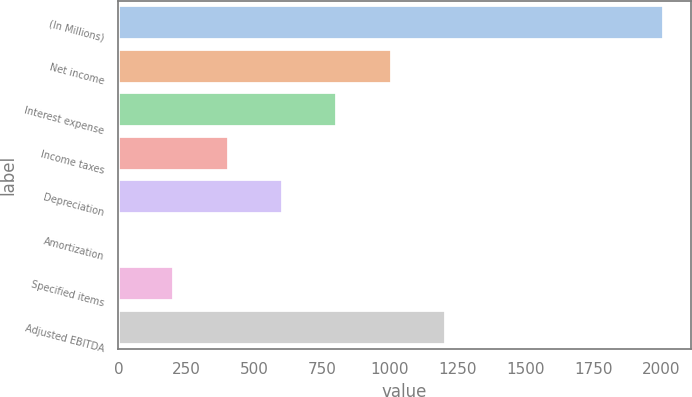Convert chart. <chart><loc_0><loc_0><loc_500><loc_500><bar_chart><fcel>(In Millions)<fcel>Net income<fcel>Interest expense<fcel>Income taxes<fcel>Depreciation<fcel>Amortization<fcel>Specified items<fcel>Adjusted EBITDA<nl><fcel>2008<fcel>1007.1<fcel>806.92<fcel>406.56<fcel>606.74<fcel>6.2<fcel>206.38<fcel>1207.28<nl></chart> 